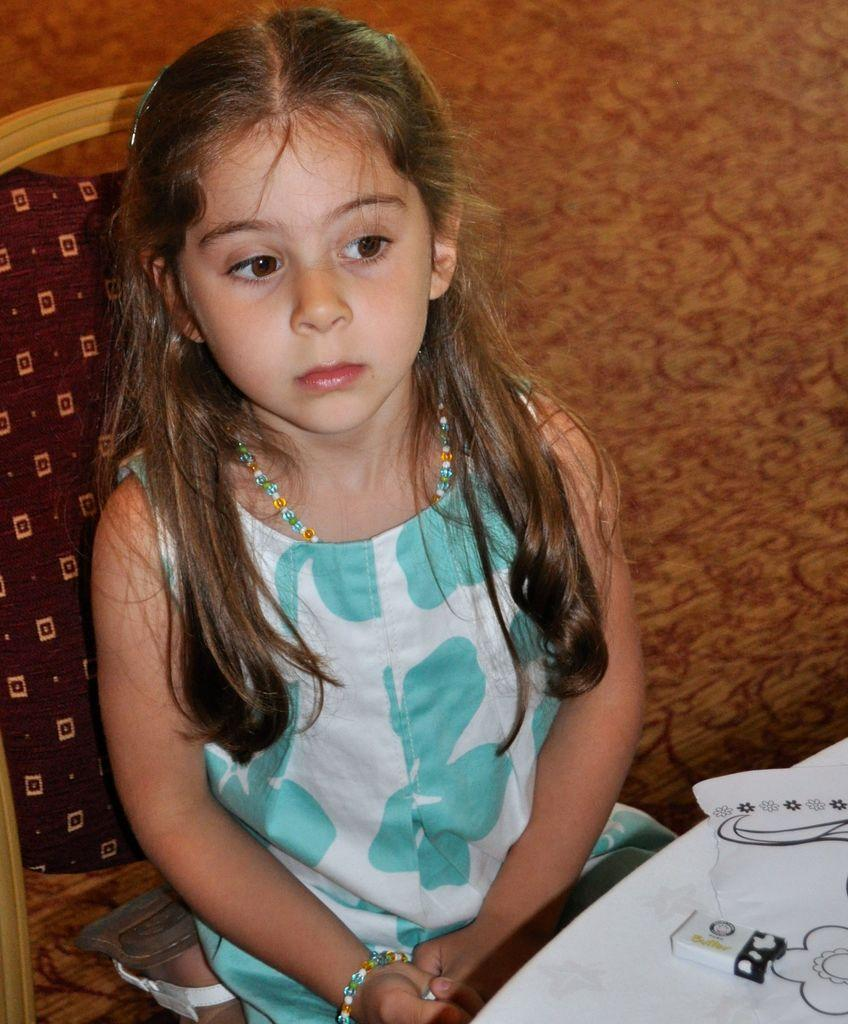Who is the main subject in the image? There is a girl in the image. What is the girl doing in the image? The girl is sitting on a chair. What can be seen in the background of the image? There is a wall and a table in the background of the image. What type of coal is being used by the girl in the image? There is no coal present in the image. What class is the girl attending in the image? The image does not show the girl attending a class. 